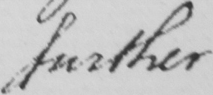Can you read and transcribe this handwriting? further 